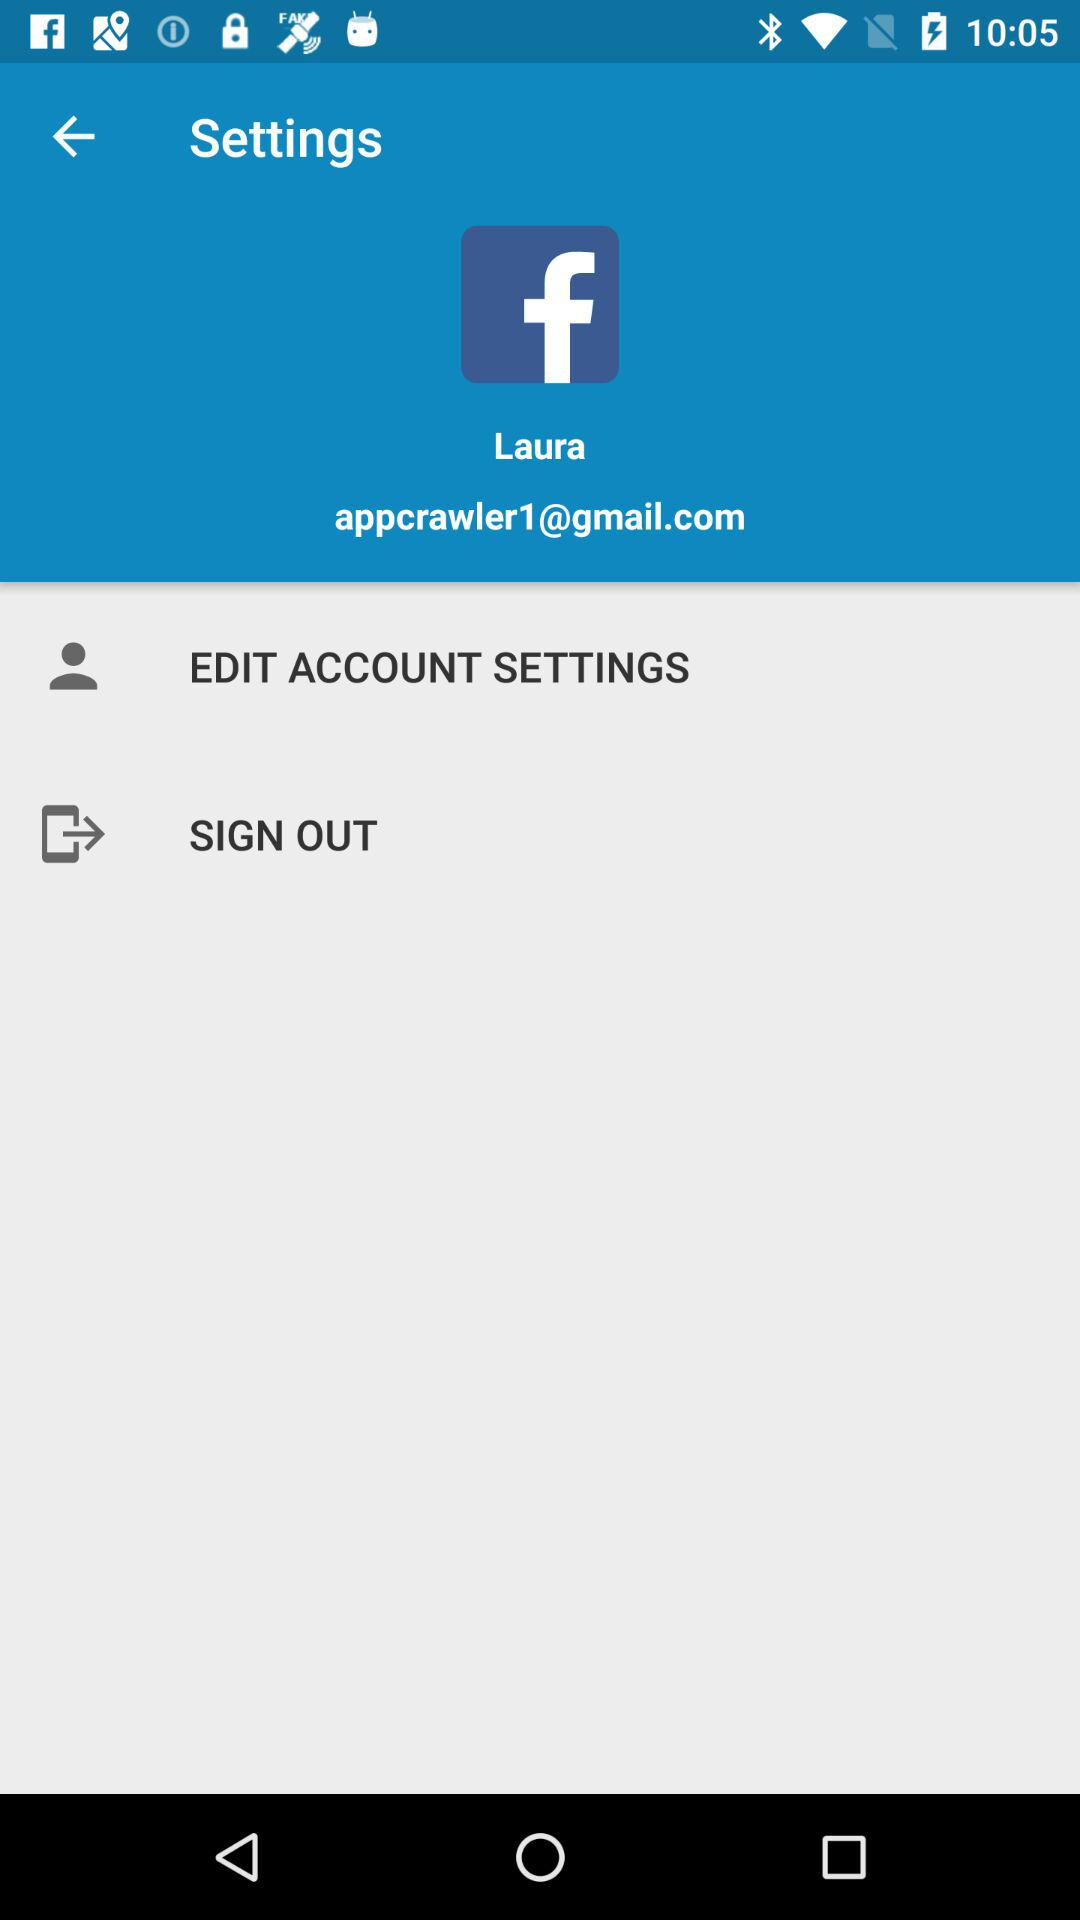What is the app name? The app name is "Facebook". 